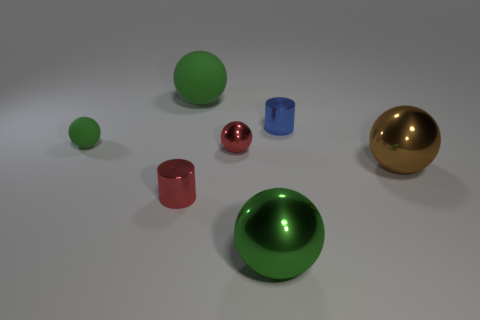There is a big matte thing that is the same color as the tiny matte ball; what is its shape? sphere 